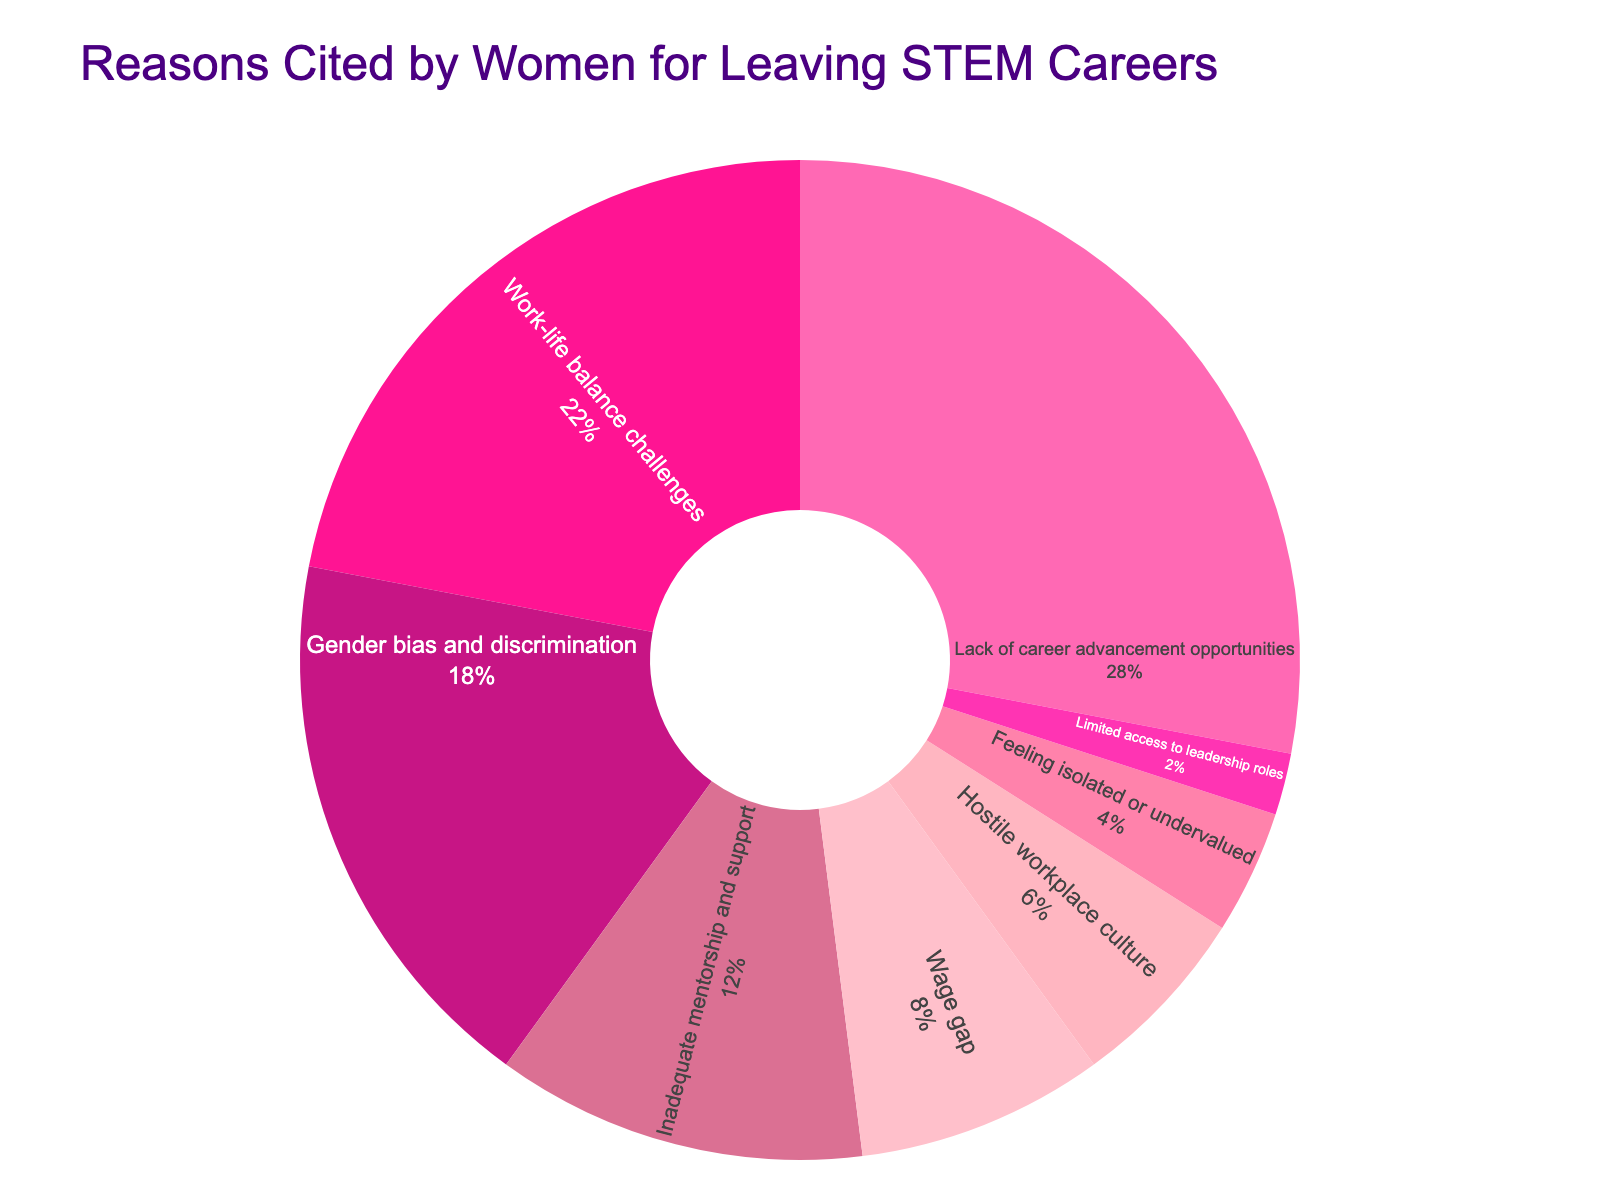What percentage of women cited work-life balance challenges as a reason for leaving STEM careers? Refer to the pie chart section labeled "Work-life balance challenges". The percentage value stated there is 22%.
Answer: 22% What is the combined percentage of women citing lack of career advancement opportunities and work-life balance challenges? Add the percentages for lack of career advancement opportunities (28%) and work-life balance challenges (22%). The sum is 28% + 22% = 50%.
Answer: 50% Which reason includes the least percentage of women for leaving STEM careers? Look for the smallest segment in the pie chart. The smallest segment is labeled "Limited access to leadership roles" with a percentage value of 2%.
Answer: Limited access to leadership roles How much more does lack of career advancement opportunities account for the departures compared to wage gap? Subtract the percentage for wage gap (8%) from the percentage for lack of career advancement opportunities (28%). The difference is 28% - 8% = 20%.
Answer: 20% Which reason is cited more frequently: gender bias and discrimination or inadequate mentorship and support? Compare the percentages for gender bias and discrimination (18%) and inadequate mentorship and support (12%). Gender bias and discrimination (18%) is cited more frequently.
Answer: Gender bias and discrimination If you combine the percentages of the three least cited reasons, what is the total? Add the percentages of the three least cited reasons: limited access to leadership roles (2%), feeling isolated or undervalued (4%), and hostile workplace culture (6%). The combined total is 2% + 4% + 6% = 12%.
Answer: 12% Is the combined percentage of inadequate mentorship and support and wage gap greater than the percentage for gender bias and discrimination? Add the percentages for inadequate mentorship and support (12%) and wage gap (8%), then compare the sum (12% + 8% = 20%) to the percentage for gender bias and discrimination (18%). 20% is greater than 18%.
Answer: Yes Which color is used to represent gender bias and discrimination in the pie chart? Identify the color of the segment labeled "Gender bias and discrimination" in the pie chart. It is represented by a specific shade of color based on the chart legend.
Answer: Pink (as observed from the color scheme given) What is the difference in percentage between work-life balance challenges and hostile workplace culture? Subtract the percentage for hostile workplace culture (6%) from the percentage for work-life balance challenges (22%). The difference is 22% - 6% = 16%.
Answer: 16% Which reason has a larger percentage: feeling isolated or undervalued or inadequate mentorship and support? Compare the percentages for feeling isolated or undervalued (4%) and inadequate mentorship and support (12%). Inadequate mentorship and support (12%) has a larger percentage.
Answer: Inadequate mentorship and support 